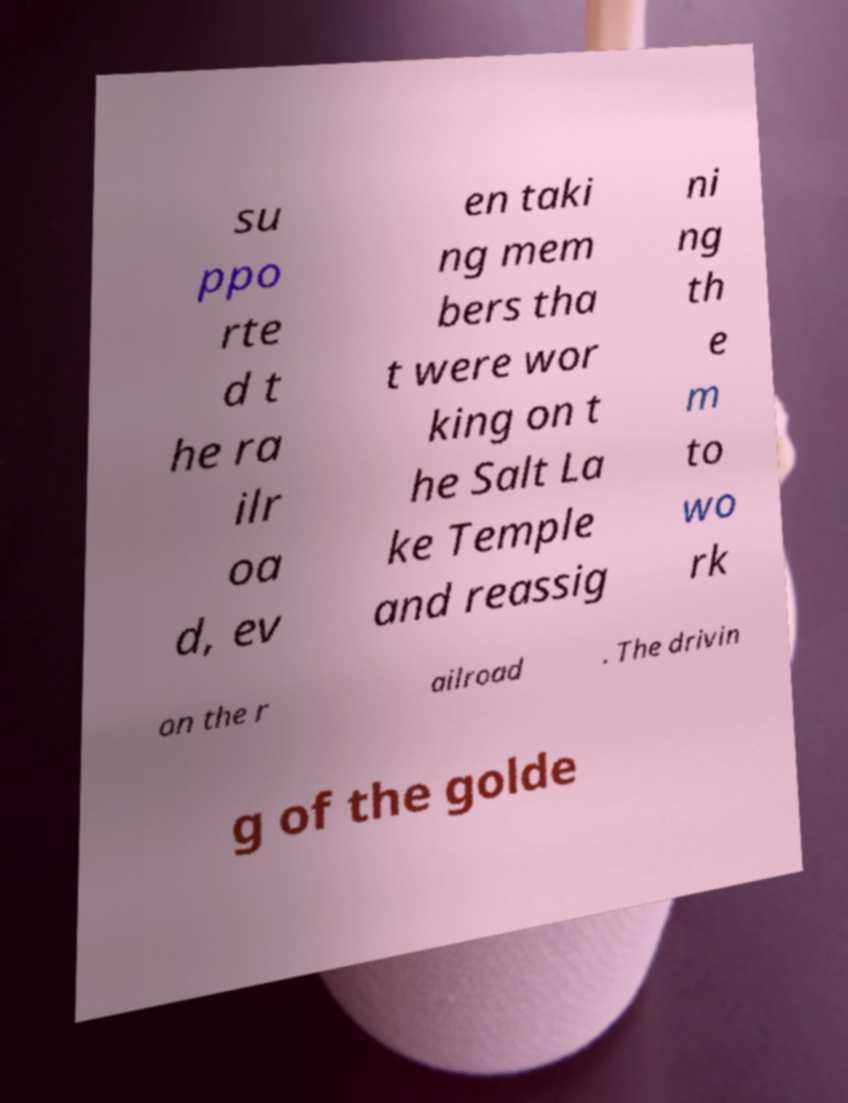Could you extract and type out the text from this image? su ppo rte d t he ra ilr oa d, ev en taki ng mem bers tha t were wor king on t he Salt La ke Temple and reassig ni ng th e m to wo rk on the r ailroad . The drivin g of the golde 